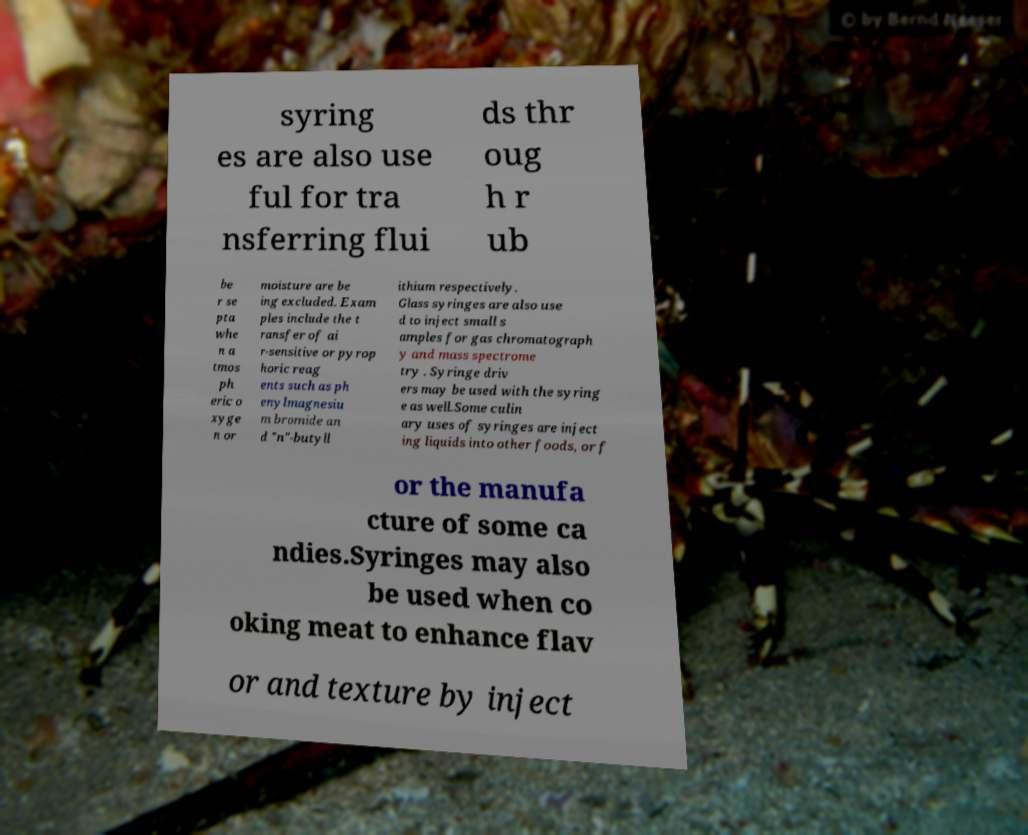Can you read and provide the text displayed in the image?This photo seems to have some interesting text. Can you extract and type it out for me? syring es are also use ful for tra nsferring flui ds thr oug h r ub be r se pta whe n a tmos ph eric o xyge n or moisture are be ing excluded. Exam ples include the t ransfer of ai r-sensitive or pyrop horic reag ents such as ph enylmagnesiu m bromide an d "n"-butyll ithium respectively. Glass syringes are also use d to inject small s amples for gas chromatograph y and mass spectrome try . Syringe driv ers may be used with the syring e as well.Some culin ary uses of syringes are inject ing liquids into other foods, or f or the manufa cture of some ca ndies.Syringes may also be used when co oking meat to enhance flav or and texture by inject 